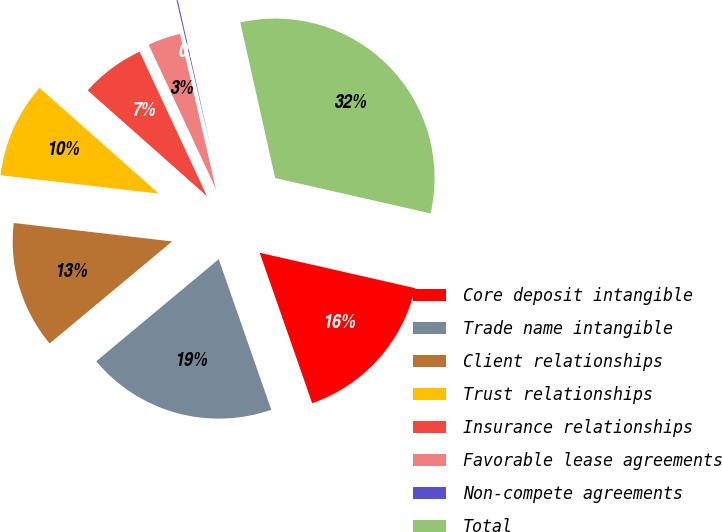<chart> <loc_0><loc_0><loc_500><loc_500><pie_chart><fcel>Core deposit intangible<fcel>Trade name intangible<fcel>Client relationships<fcel>Trust relationships<fcel>Insurance relationships<fcel>Favorable lease agreements<fcel>Non-compete agreements<fcel>Total<nl><fcel>16.09%<fcel>19.29%<fcel>12.9%<fcel>9.7%<fcel>6.51%<fcel>3.32%<fcel>0.12%<fcel>32.07%<nl></chart> 